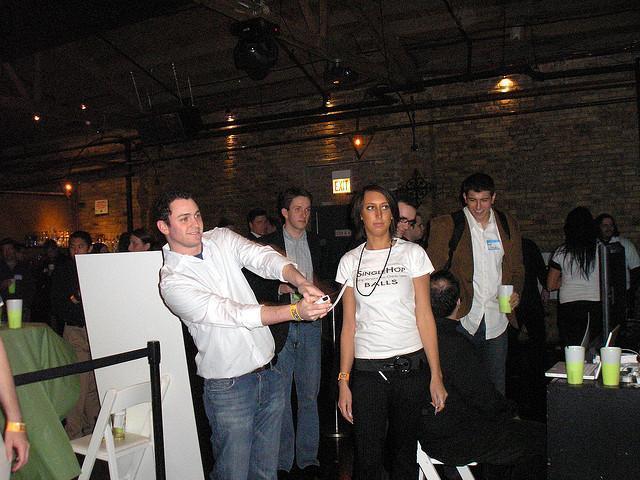How many people can you see?
Give a very brief answer. 9. How many of these motorcycles are actually being ridden?
Give a very brief answer. 0. 